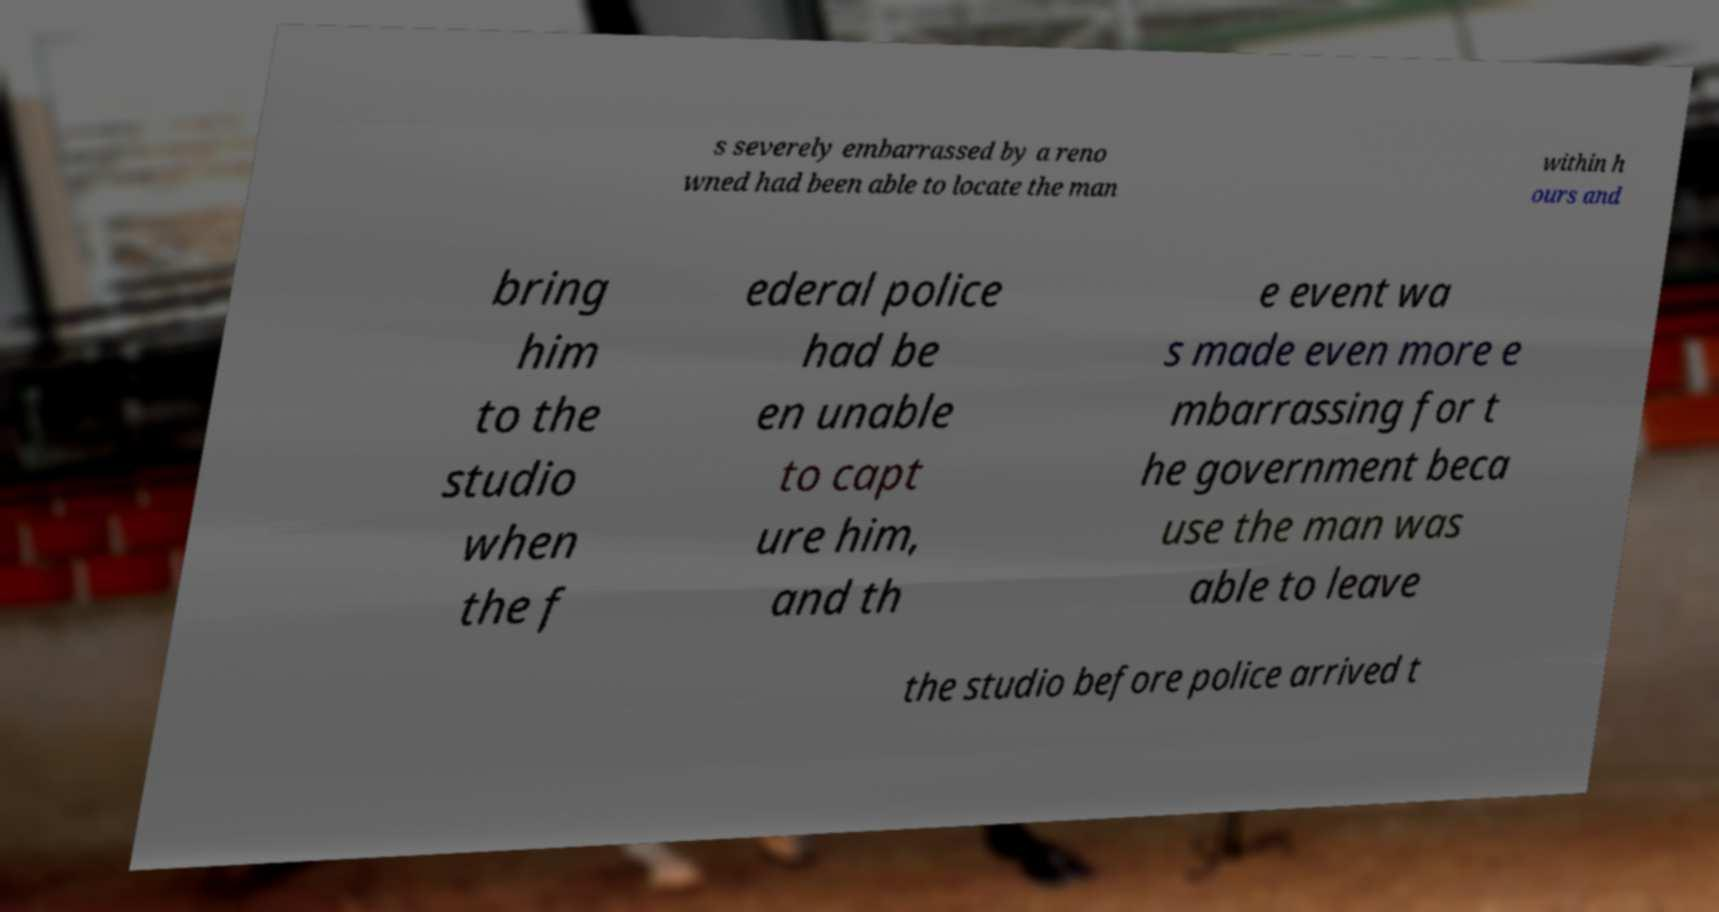Please read and relay the text visible in this image. What does it say? s severely embarrassed by a reno wned had been able to locate the man within h ours and bring him to the studio when the f ederal police had be en unable to capt ure him, and th e event wa s made even more e mbarrassing for t he government beca use the man was able to leave the studio before police arrived t 